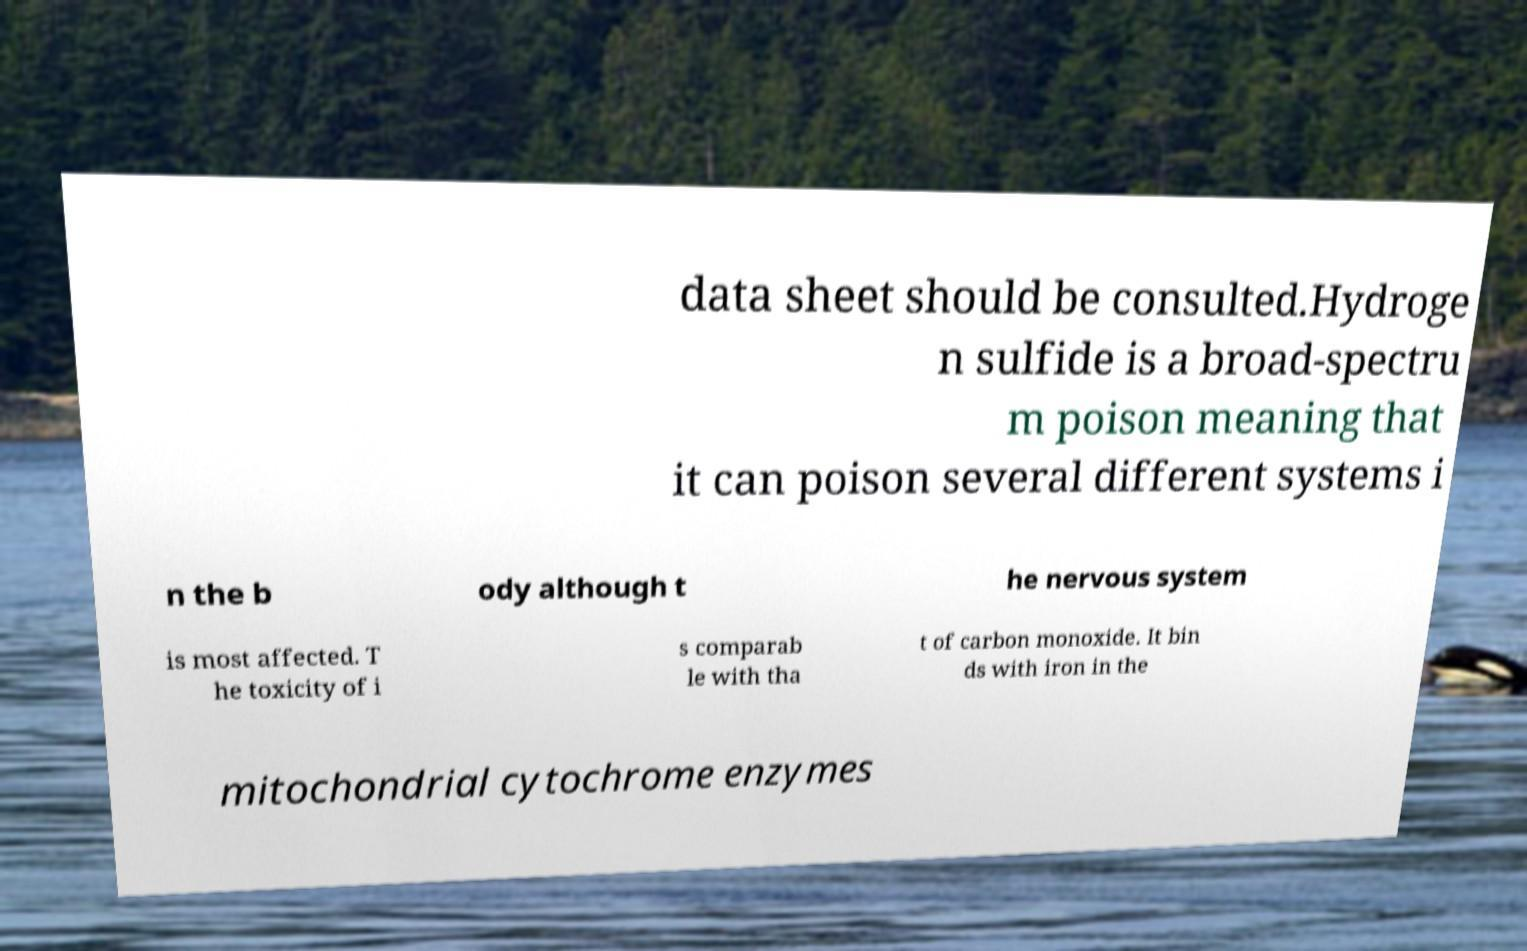Can you accurately transcribe the text from the provided image for me? data sheet should be consulted.Hydroge n sulfide is a broad-spectru m poison meaning that it can poison several different systems i n the b ody although t he nervous system is most affected. T he toxicity of i s comparab le with tha t of carbon monoxide. It bin ds with iron in the mitochondrial cytochrome enzymes 